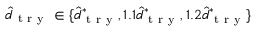<formula> <loc_0><loc_0><loc_500><loc_500>\hat { d } _ { t r y } \in \{ \hat { d } _ { t r y } ^ { * } , 1 . 1 \hat { d } _ { t r y } ^ { * } , 1 . 2 \hat { d } _ { t r y } ^ { * } \}</formula> 